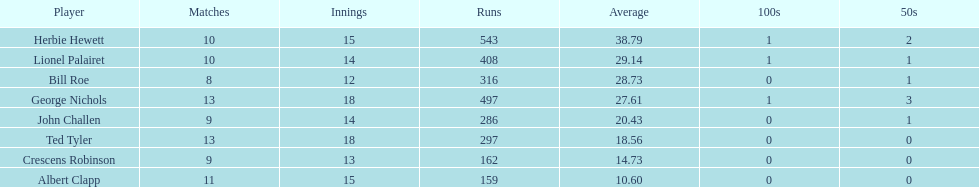Which player scored the lowest amount of runs? Albert Clapp. 